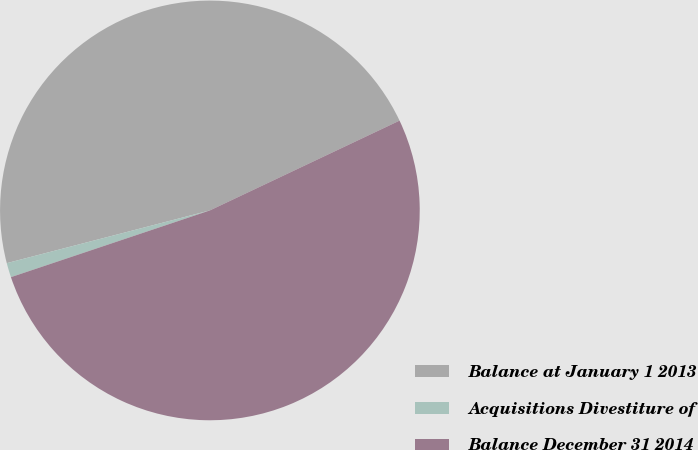Convert chart to OTSL. <chart><loc_0><loc_0><loc_500><loc_500><pie_chart><fcel>Balance at January 1 2013<fcel>Acquisitions Divestiture of<fcel>Balance December 31 2014<nl><fcel>47.01%<fcel>1.11%<fcel>51.89%<nl></chart> 